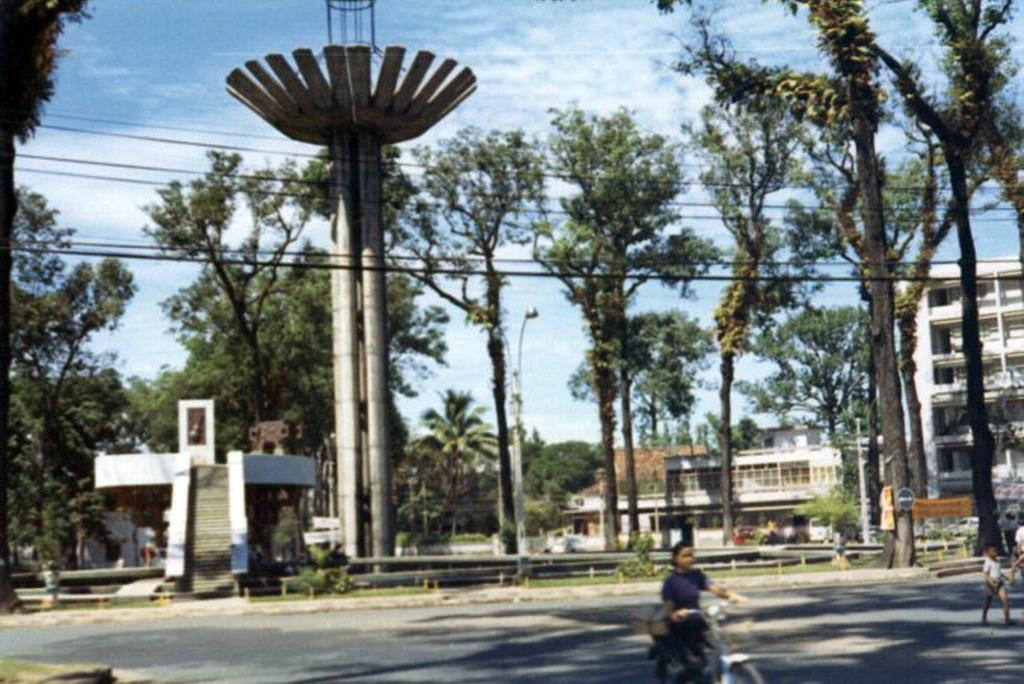In one or two sentences, can you explain what this image depicts? In this image we can see a three people, one of them is riding on the bicycle, there are some trees, plants, pole, buildings, wires, also we can see the sky. 